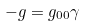<formula> <loc_0><loc_0><loc_500><loc_500>- g = g _ { 0 0 } \gamma</formula> 